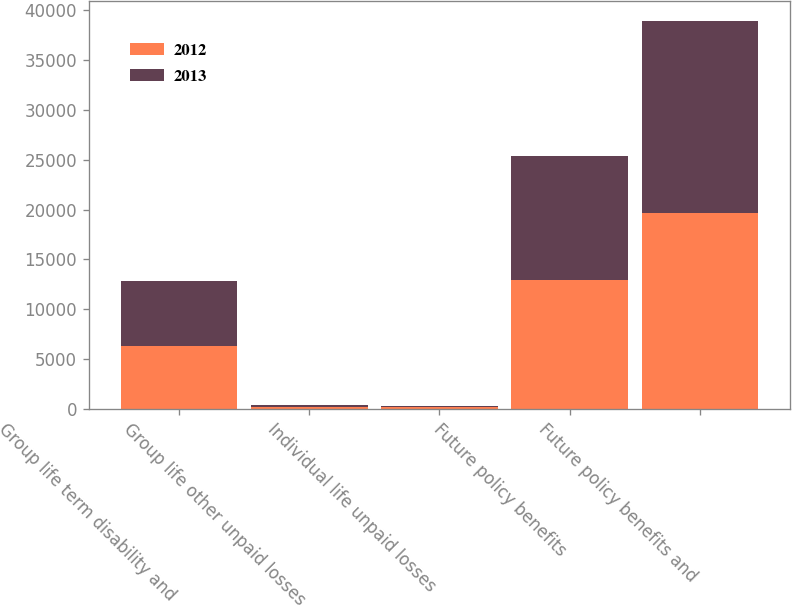<chart> <loc_0><loc_0><loc_500><loc_500><stacked_bar_chart><ecel><fcel>Group life term disability and<fcel>Group life other unpaid losses<fcel>Individual life unpaid losses<fcel>Future policy benefits<fcel>Future policy benefits and<nl><fcel>2012<fcel>6308<fcel>206<fcel>167<fcel>12988<fcel>19669<nl><fcel>2013<fcel>6547<fcel>206<fcel>173<fcel>12350<fcel>19276<nl></chart> 